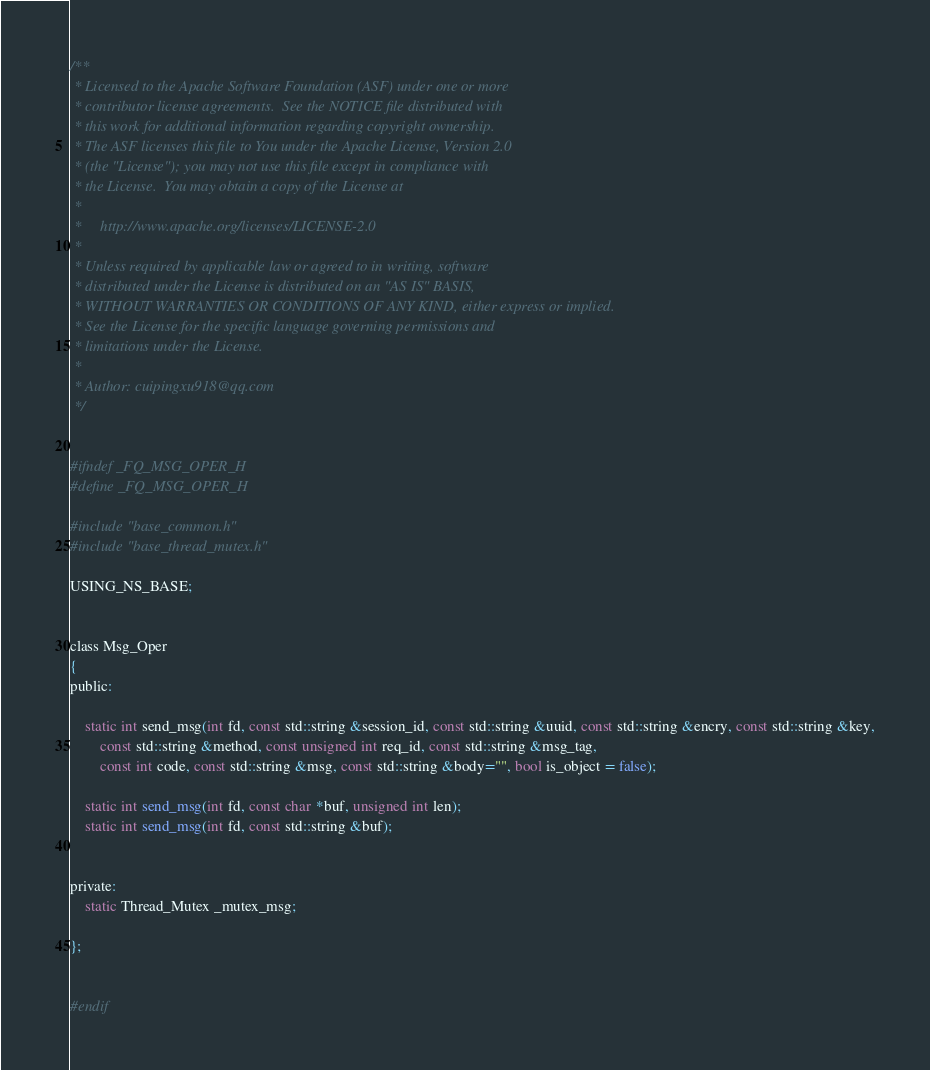<code> <loc_0><loc_0><loc_500><loc_500><_C_>
/**
 * Licensed to the Apache Software Foundation (ASF) under one or more
 * contributor license agreements.  See the NOTICE file distributed with
 * this work for additional information regarding copyright ownership.
 * The ASF licenses this file to You under the Apache License, Version 2.0
 * (the "License"); you may not use this file except in compliance with
 * the License.  You may obtain a copy of the License at
 *
 *     http://www.apache.org/licenses/LICENSE-2.0
 *
 * Unless required by applicable law or agreed to in writing, software
 * distributed under the License is distributed on an "AS IS" BASIS,
 * WITHOUT WARRANTIES OR CONDITIONS OF ANY KIND, either express or implied.
 * See the License for the specific language governing permissions and
 * limitations under the License.
 *
 * Author: cuipingxu918@qq.com
 */


#ifndef _FQ_MSG_OPER_H
#define _FQ_MSG_OPER_H

#include "base_common.h"
#include "base_thread_mutex.h"

USING_NS_BASE;


class Msg_Oper
{
public:

	static int send_msg(int fd, const std::string &session_id, const std::string &uuid, const std::string &encry, const std::string &key,
		const std::string &method, const unsigned int req_id, const std::string &msg_tag,
		const int code, const std::string &msg, const std::string &body="", bool is_object = false);

	static int send_msg(int fd, const char *buf, unsigned int len);
	static int send_msg(int fd, const std::string &buf);


private:
	static Thread_Mutex _mutex_msg;

};


#endif


</code> 